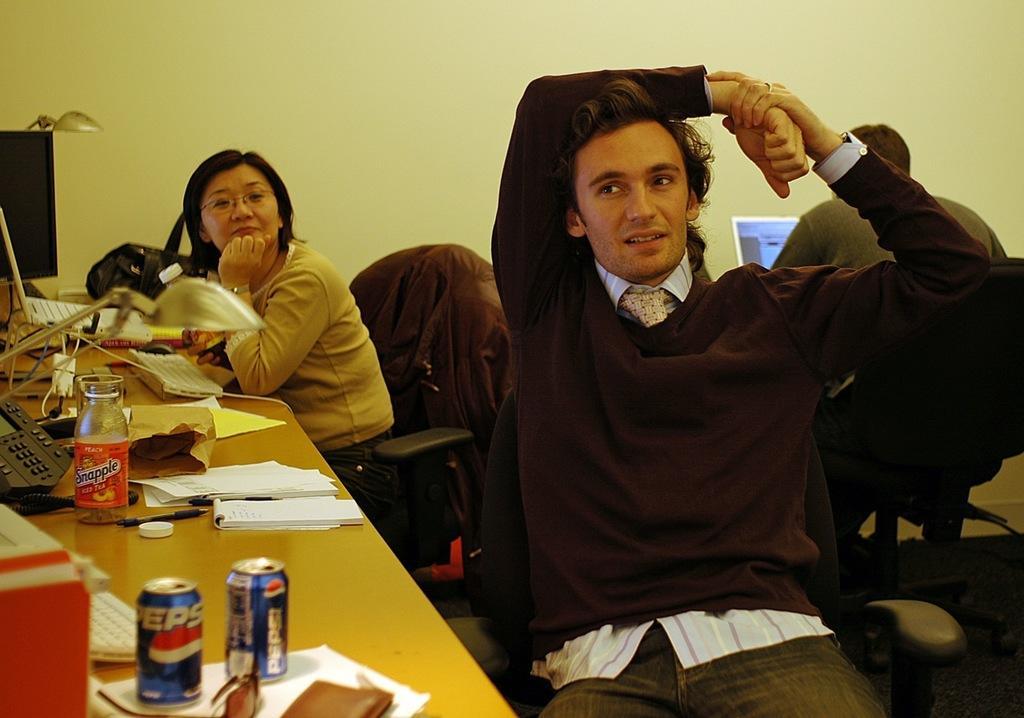Can you describe this image briefly? The image is inside the room. In the image there are three people sitting on chair in front of a table, on table we can see books,pen,tin,bottle,land phone,monitor,keyboard,mouse,bag,cap,purse and goggles. In background there is a wall. 